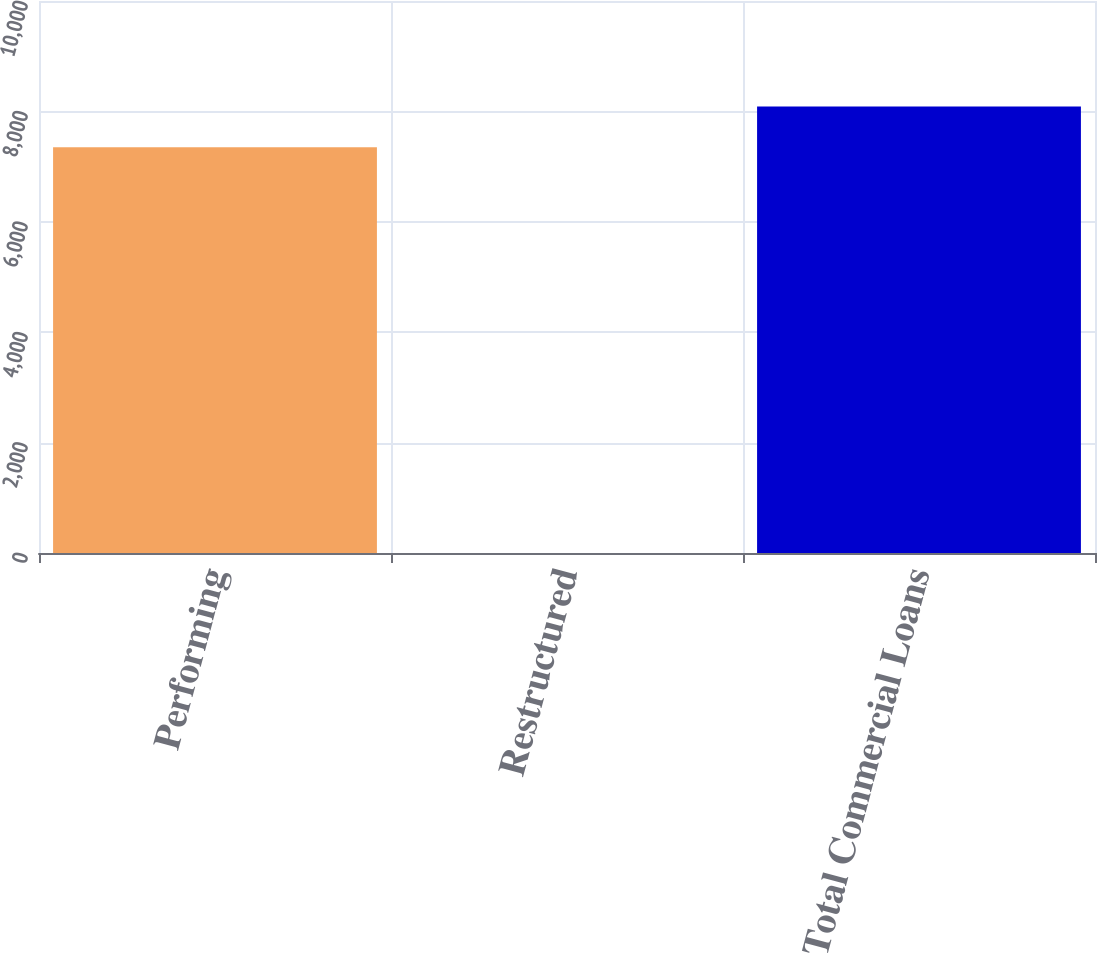<chart> <loc_0><loc_0><loc_500><loc_500><bar_chart><fcel>Performing<fcel>Restructured<fcel>Total Commercial Loans<nl><fcel>7352<fcel>1<fcel>8087.2<nl></chart> 